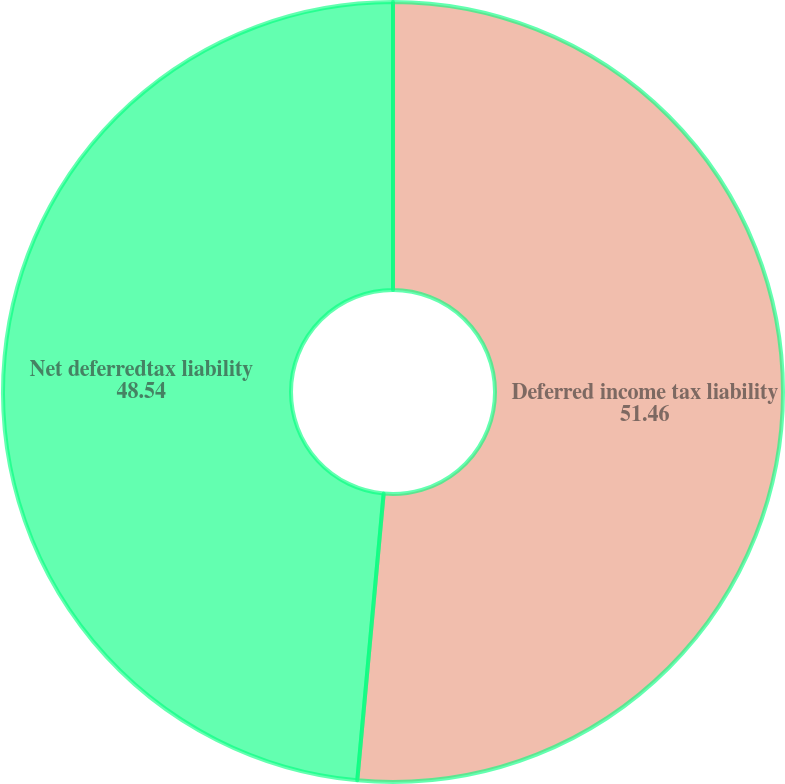Convert chart. <chart><loc_0><loc_0><loc_500><loc_500><pie_chart><fcel>Deferred income tax liability<fcel>Net deferredtax liability<nl><fcel>51.46%<fcel>48.54%<nl></chart> 